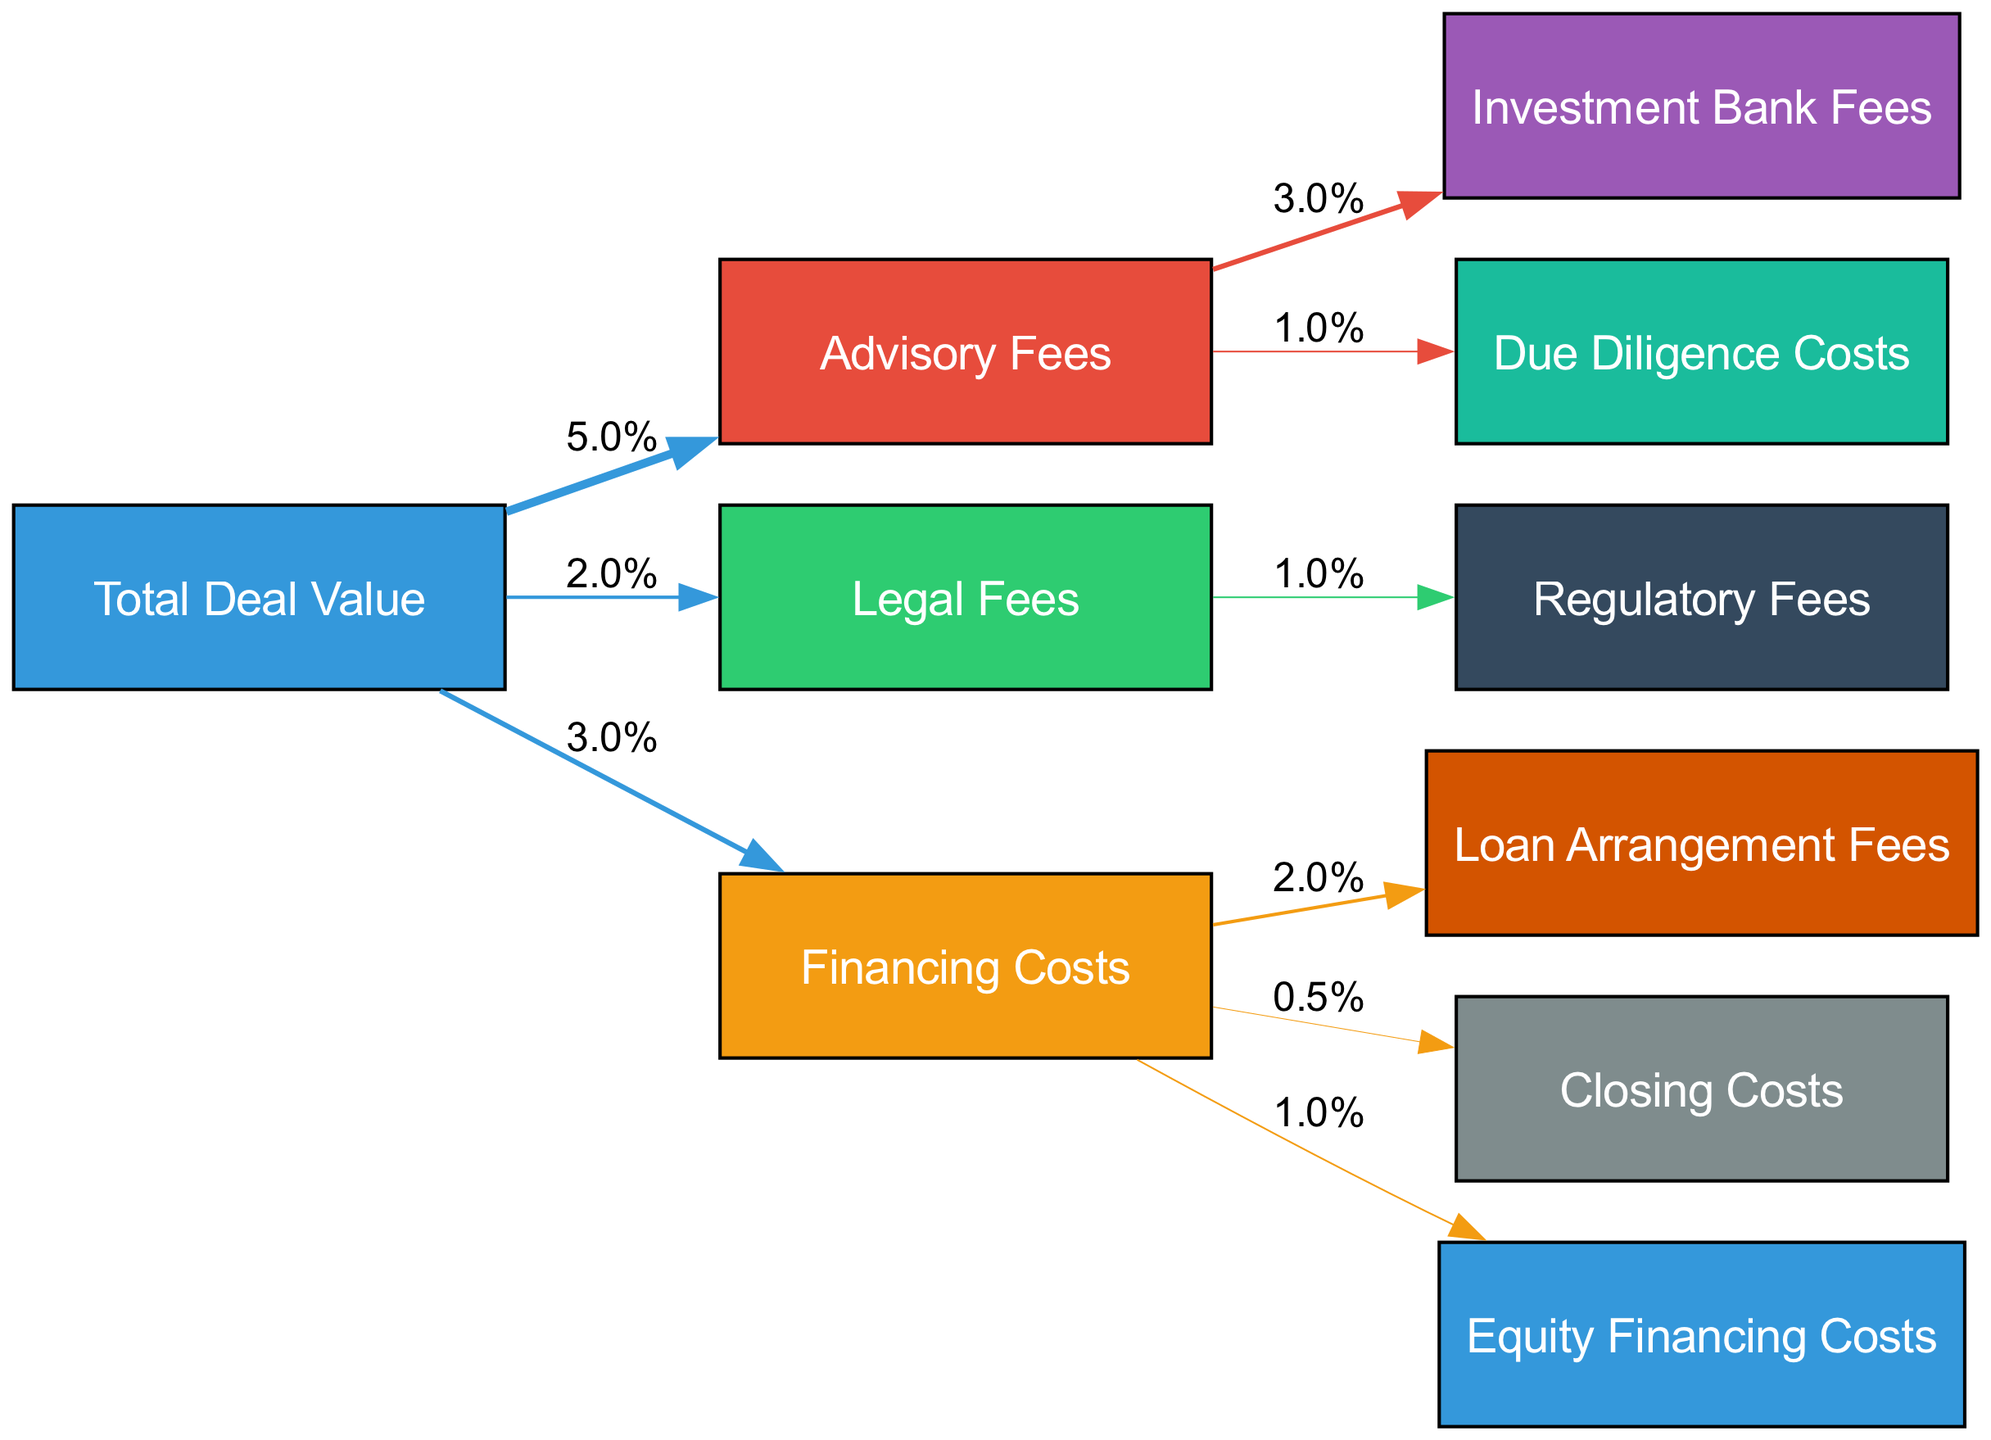What is the total percentage allocated to advisory fees? The diagram shows that advisory fees represent 5% of the total deal value, as indicated by the link from "Total Deal Value" to "Advisory Fees" labeled with 5%.
Answer: 5% What percentage of legal fees are allocated to regulatory fees? According to the diagram, legal fees account for 2% of the total deal value, and out of those legal fees, 1% is directed to regulatory fees, which is indicated by the link from "Legal Fees" to "Regulatory Fees."
Answer: 1% How many different fees and costs are shown in the diagram? The diagram displays a total of 10 different nodes, which include various fees and costs categories. This can be counted directly from the visual representation.
Answer: 10 What is the total percentage allocated to financing costs? Financing costs are illustrated with a single link from the "Total Deal Value" to "Financing Costs," representing 3% of the total deal value.
Answer: 3% What percentage of advisory fees are allocated to due diligence costs? The diagram indicates that of the total advisory fees (5%), 1% is allocated to due diligence costs, shown by the link from "Advisory Fees" to "Due Diligence Costs." Thus, the percentage of advisory fees going to due diligence is 1%.
Answer: 1% Which cost category has the highest percentage allocation? By examining the various nodes and their connections, the advisory fees node indicates the highest percentage allocation at 5%, as it is the only node pointing to two others, indicating a split of the overall advisory fees.
Answer: Advisory Fees Which cost category has the lowest percentage allocation? The diagram indicates that closing costs have the lowest allocation, at 0.5%, as shown by the link from "Financing Costs" to "Closing Costs." This can be identified by observing the smaller value next to the link.
Answer: 0.5% What percentage of financing costs is attributed to loan arrangement fees? The financing costs (3%) have a direct link to loan arrangement fees, which is allocated 2%. Thus, the percentage of financing costs allocated to loan arrangement fees can be directly referenced from the link.
Answer: 2% How many edges does the diagram contain? The diagram has a total of 8 links (edges) connecting the nodes. Counting from the connections between nodes provides the accurate number of relationships shown in the diagram.
Answer: 8 